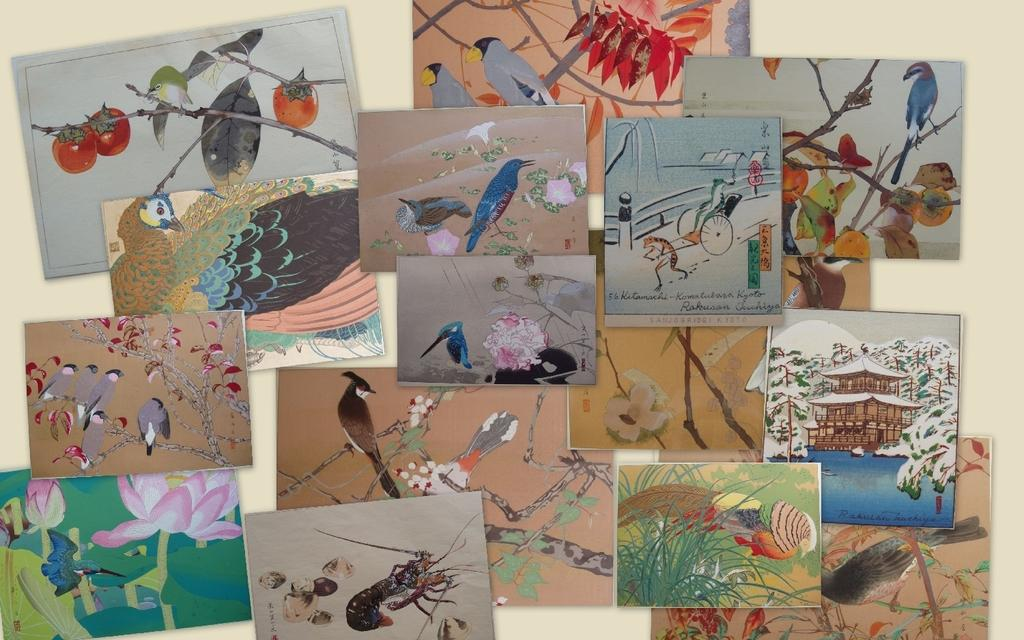What type of artwork is depicted in the image? There are painted pictures of birds and different animals in the image. Can you describe the subjects of the paintings? The paintings feature birds and other animals. What is the weight of the apple in the image? There is no apple present in the image, so it is not possible to determine its weight. 